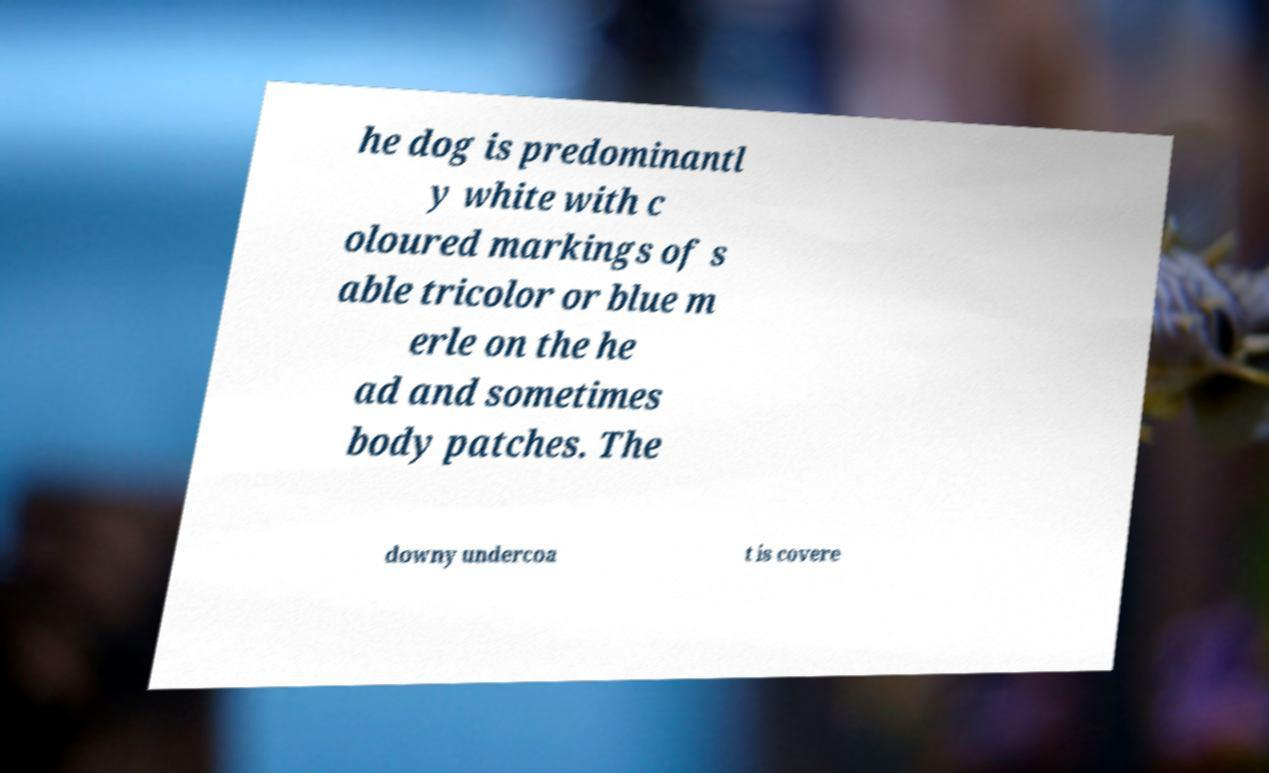I need the written content from this picture converted into text. Can you do that? he dog is predominantl y white with c oloured markings of s able tricolor or blue m erle on the he ad and sometimes body patches. The downy undercoa t is covere 